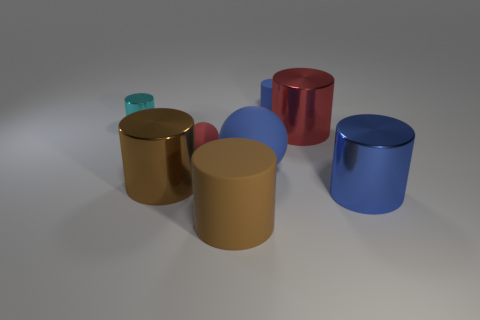Add 1 big matte balls. How many objects exist? 9 Subtract all green balls. How many brown cylinders are left? 2 Subtract all red cylinders. How many cylinders are left? 5 Subtract all cyan cylinders. How many cylinders are left? 5 Subtract 2 cylinders. How many cylinders are left? 4 Subtract all balls. How many objects are left? 6 Subtract 0 green cylinders. How many objects are left? 8 Subtract all cyan cylinders. Subtract all yellow blocks. How many cylinders are left? 5 Subtract all blue matte cylinders. Subtract all cyan objects. How many objects are left? 6 Add 1 large brown matte cylinders. How many large brown matte cylinders are left? 2 